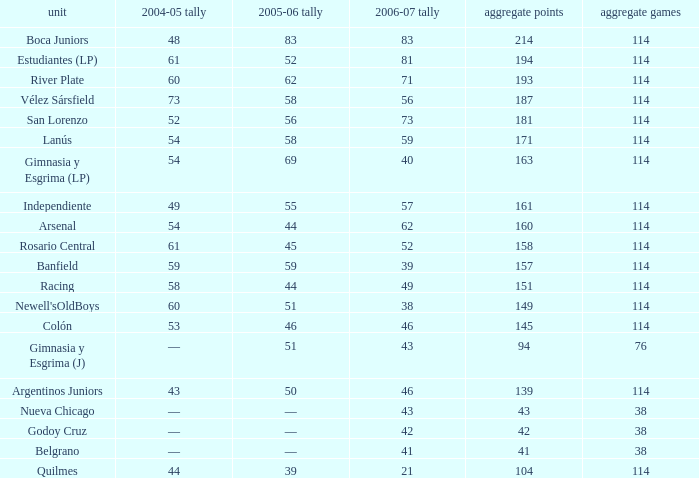What is the cumulative number of pld for team arsenal? 1.0. 